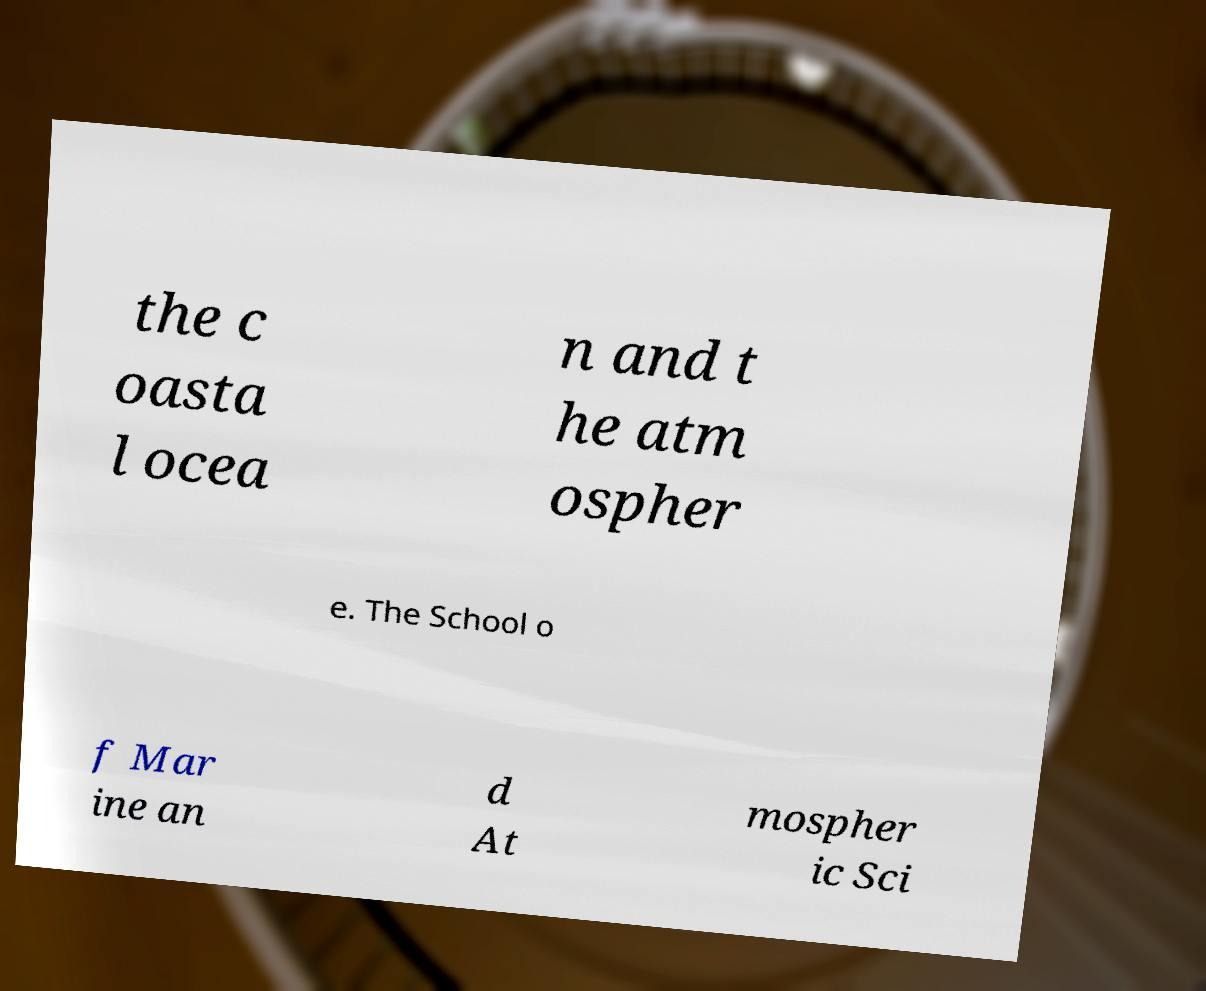There's text embedded in this image that I need extracted. Can you transcribe it verbatim? the c oasta l ocea n and t he atm ospher e. The School o f Mar ine an d At mospher ic Sci 